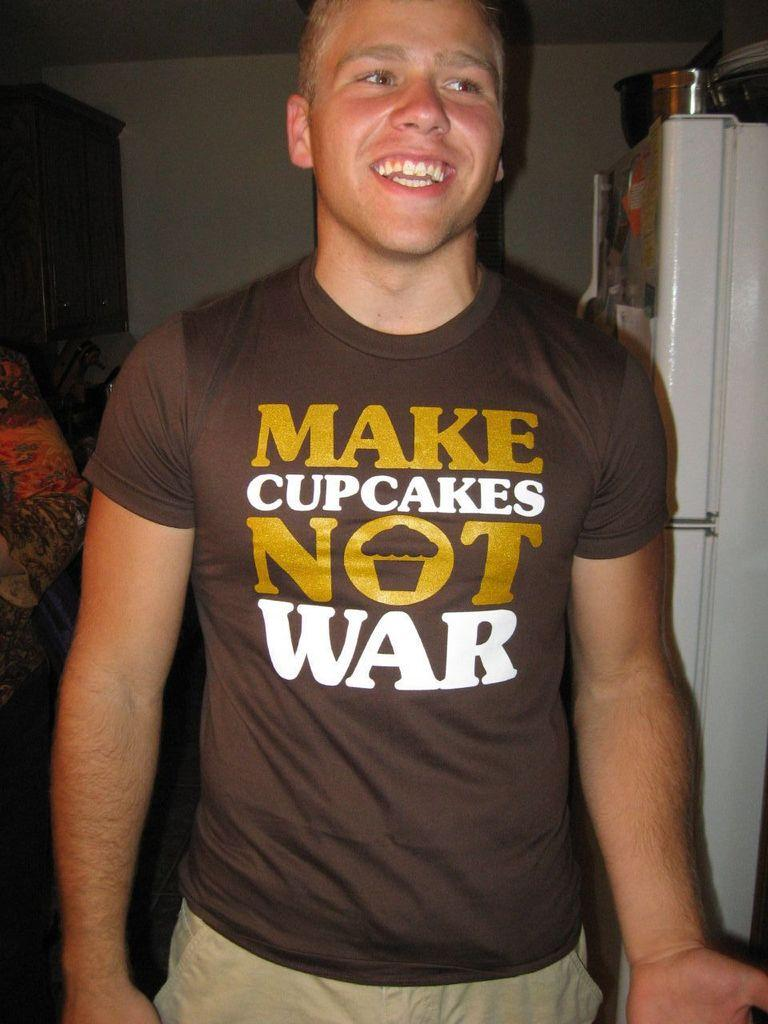Provide a one-sentence caption for the provided image. A young man smiling and wearing a tight brown shirt which reads Make cupcakes and not war. 